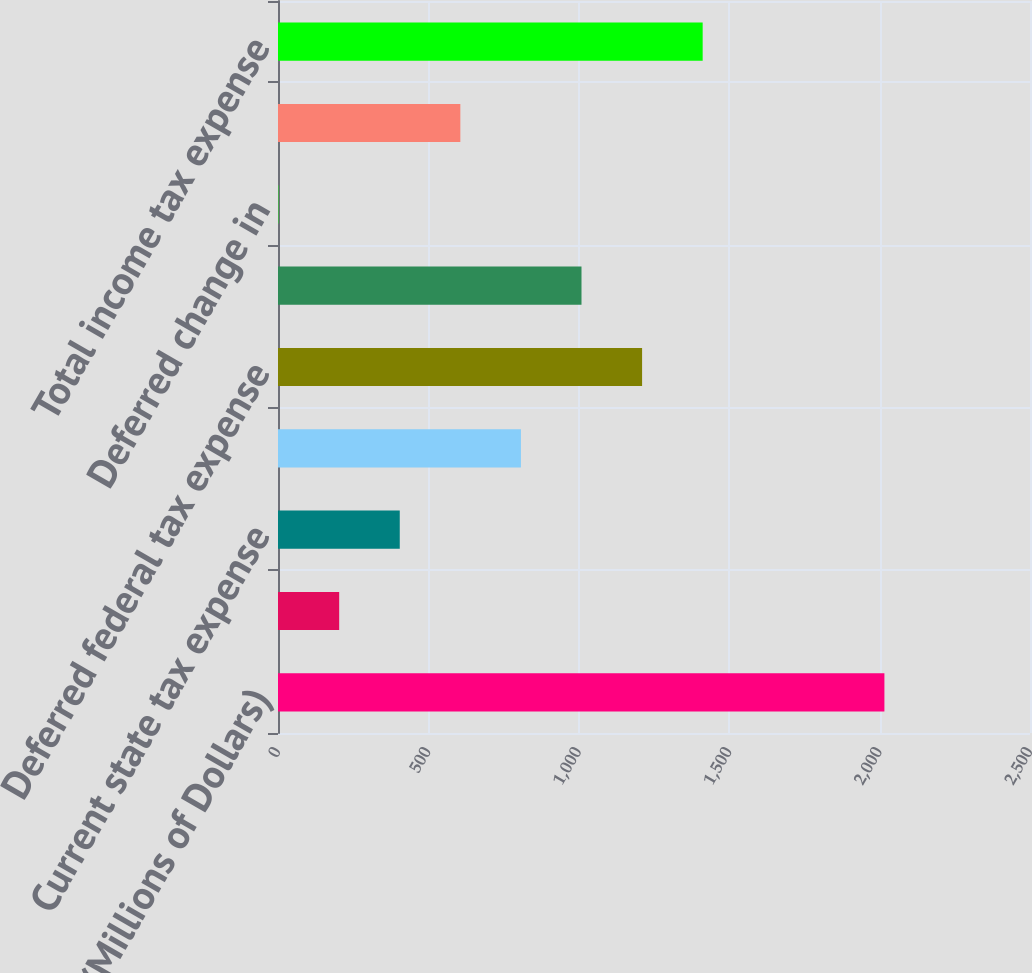<chart> <loc_0><loc_0><loc_500><loc_500><bar_chart><fcel>(Millions of Dollars)<fcel>Current federal tax (benefit)<fcel>Current state tax expense<fcel>Current change in unrecognized<fcel>Deferred federal tax expense<fcel>Deferred state tax expense<fcel>Deferred change in<fcel>Deferred investment tax<fcel>Total income tax expense<nl><fcel>2016<fcel>203.4<fcel>404.8<fcel>807.6<fcel>1210.4<fcel>1009<fcel>2<fcel>606.2<fcel>1411.8<nl></chart> 